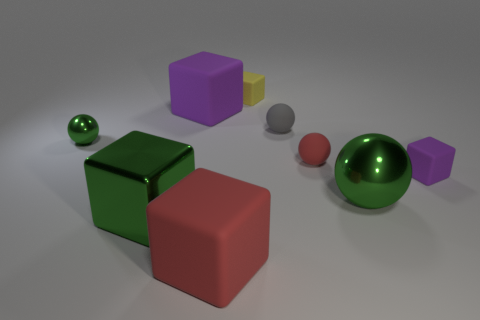There is a shiny thing right of the large green block; does it have the same color as the big metal block?
Ensure brevity in your answer.  Yes. There is a large shiny thing that is the same color as the big metal sphere; what is its shape?
Give a very brief answer. Cube. There is a green sphere to the right of the big object that is on the left side of the purple cube that is left of the big shiny sphere; what is its material?
Give a very brief answer. Metal. What is the color of the big rubber block behind the tiny rubber cube in front of the gray ball?
Offer a very short reply. Purple. There is a rubber ball that is the same size as the gray thing; what is its color?
Your answer should be compact. Red. What number of large objects are either green shiny objects or red shiny cylinders?
Keep it short and to the point. 2. Are there more tiny green things that are on the left side of the big green sphere than red rubber objects in front of the large red thing?
Offer a terse response. Yes. The block that is the same color as the large ball is what size?
Keep it short and to the point. Large. What number of other objects are the same size as the red rubber sphere?
Your answer should be compact. 4. Are the big block that is behind the small red object and the small green ball made of the same material?
Keep it short and to the point. No. 